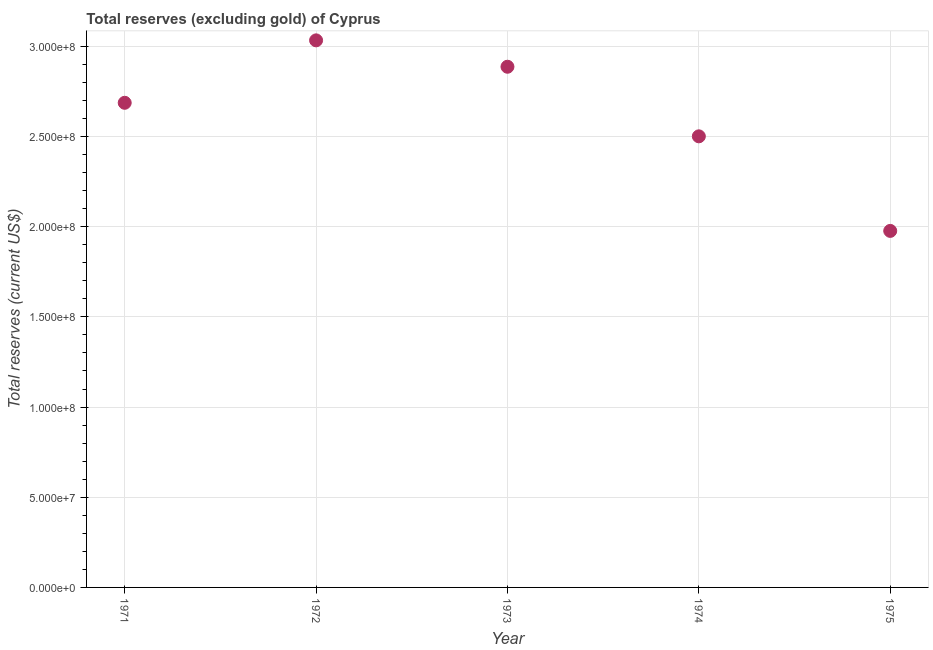What is the total reserves (excluding gold) in 1971?
Provide a succinct answer. 2.69e+08. Across all years, what is the maximum total reserves (excluding gold)?
Make the answer very short. 3.03e+08. Across all years, what is the minimum total reserves (excluding gold)?
Offer a terse response. 1.98e+08. In which year was the total reserves (excluding gold) maximum?
Your answer should be compact. 1972. In which year was the total reserves (excluding gold) minimum?
Provide a short and direct response. 1975. What is the sum of the total reserves (excluding gold)?
Offer a very short reply. 1.31e+09. What is the difference between the total reserves (excluding gold) in 1972 and 1975?
Your answer should be compact. 1.06e+08. What is the average total reserves (excluding gold) per year?
Offer a very short reply. 2.62e+08. What is the median total reserves (excluding gold)?
Make the answer very short. 2.69e+08. In how many years, is the total reserves (excluding gold) greater than 170000000 US$?
Give a very brief answer. 5. What is the ratio of the total reserves (excluding gold) in 1974 to that in 1975?
Your answer should be compact. 1.27. Is the total reserves (excluding gold) in 1972 less than that in 1974?
Give a very brief answer. No. Is the difference between the total reserves (excluding gold) in 1971 and 1975 greater than the difference between any two years?
Provide a succinct answer. No. What is the difference between the highest and the second highest total reserves (excluding gold)?
Your answer should be compact. 1.46e+07. Is the sum of the total reserves (excluding gold) in 1974 and 1975 greater than the maximum total reserves (excluding gold) across all years?
Provide a succinct answer. Yes. What is the difference between the highest and the lowest total reserves (excluding gold)?
Offer a very short reply. 1.06e+08. In how many years, is the total reserves (excluding gold) greater than the average total reserves (excluding gold) taken over all years?
Offer a terse response. 3. Does the total reserves (excluding gold) monotonically increase over the years?
Give a very brief answer. No. How many years are there in the graph?
Ensure brevity in your answer.  5. What is the difference between two consecutive major ticks on the Y-axis?
Make the answer very short. 5.00e+07. Are the values on the major ticks of Y-axis written in scientific E-notation?
Ensure brevity in your answer.  Yes. Does the graph contain any zero values?
Give a very brief answer. No. Does the graph contain grids?
Your answer should be very brief. Yes. What is the title of the graph?
Give a very brief answer. Total reserves (excluding gold) of Cyprus. What is the label or title of the Y-axis?
Make the answer very short. Total reserves (current US$). What is the Total reserves (current US$) in 1971?
Keep it short and to the point. 2.69e+08. What is the Total reserves (current US$) in 1972?
Your answer should be very brief. 3.03e+08. What is the Total reserves (current US$) in 1973?
Your response must be concise. 2.89e+08. What is the Total reserves (current US$) in 1974?
Provide a short and direct response. 2.50e+08. What is the Total reserves (current US$) in 1975?
Ensure brevity in your answer.  1.98e+08. What is the difference between the Total reserves (current US$) in 1971 and 1972?
Provide a short and direct response. -3.46e+07. What is the difference between the Total reserves (current US$) in 1971 and 1973?
Make the answer very short. -2.00e+07. What is the difference between the Total reserves (current US$) in 1971 and 1974?
Provide a short and direct response. 1.86e+07. What is the difference between the Total reserves (current US$) in 1971 and 1975?
Ensure brevity in your answer.  7.10e+07. What is the difference between the Total reserves (current US$) in 1972 and 1973?
Your response must be concise. 1.46e+07. What is the difference between the Total reserves (current US$) in 1972 and 1974?
Your answer should be compact. 5.32e+07. What is the difference between the Total reserves (current US$) in 1972 and 1975?
Ensure brevity in your answer.  1.06e+08. What is the difference between the Total reserves (current US$) in 1973 and 1974?
Make the answer very short. 3.86e+07. What is the difference between the Total reserves (current US$) in 1973 and 1975?
Offer a terse response. 9.10e+07. What is the difference between the Total reserves (current US$) in 1974 and 1975?
Give a very brief answer. 5.24e+07. What is the ratio of the Total reserves (current US$) in 1971 to that in 1972?
Give a very brief answer. 0.89. What is the ratio of the Total reserves (current US$) in 1971 to that in 1973?
Give a very brief answer. 0.93. What is the ratio of the Total reserves (current US$) in 1971 to that in 1974?
Give a very brief answer. 1.07. What is the ratio of the Total reserves (current US$) in 1971 to that in 1975?
Give a very brief answer. 1.36. What is the ratio of the Total reserves (current US$) in 1972 to that in 1973?
Make the answer very short. 1.05. What is the ratio of the Total reserves (current US$) in 1972 to that in 1974?
Keep it short and to the point. 1.21. What is the ratio of the Total reserves (current US$) in 1972 to that in 1975?
Ensure brevity in your answer.  1.53. What is the ratio of the Total reserves (current US$) in 1973 to that in 1974?
Make the answer very short. 1.15. What is the ratio of the Total reserves (current US$) in 1973 to that in 1975?
Your answer should be very brief. 1.46. What is the ratio of the Total reserves (current US$) in 1974 to that in 1975?
Keep it short and to the point. 1.26. 